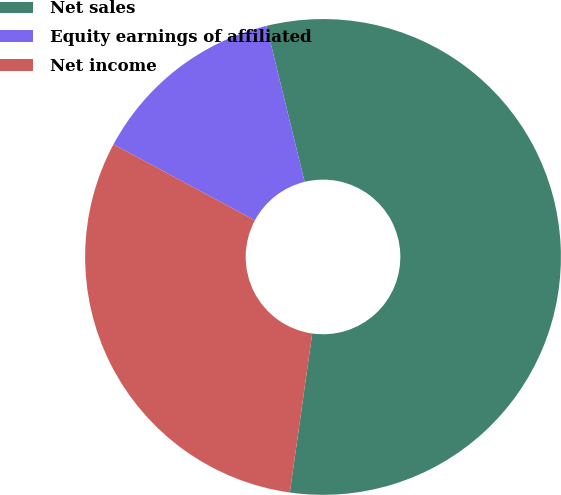Convert chart. <chart><loc_0><loc_0><loc_500><loc_500><pie_chart><fcel>Net sales<fcel>Equity earnings of affiliated<fcel>Net income<nl><fcel>56.05%<fcel>13.33%<fcel>30.62%<nl></chart> 